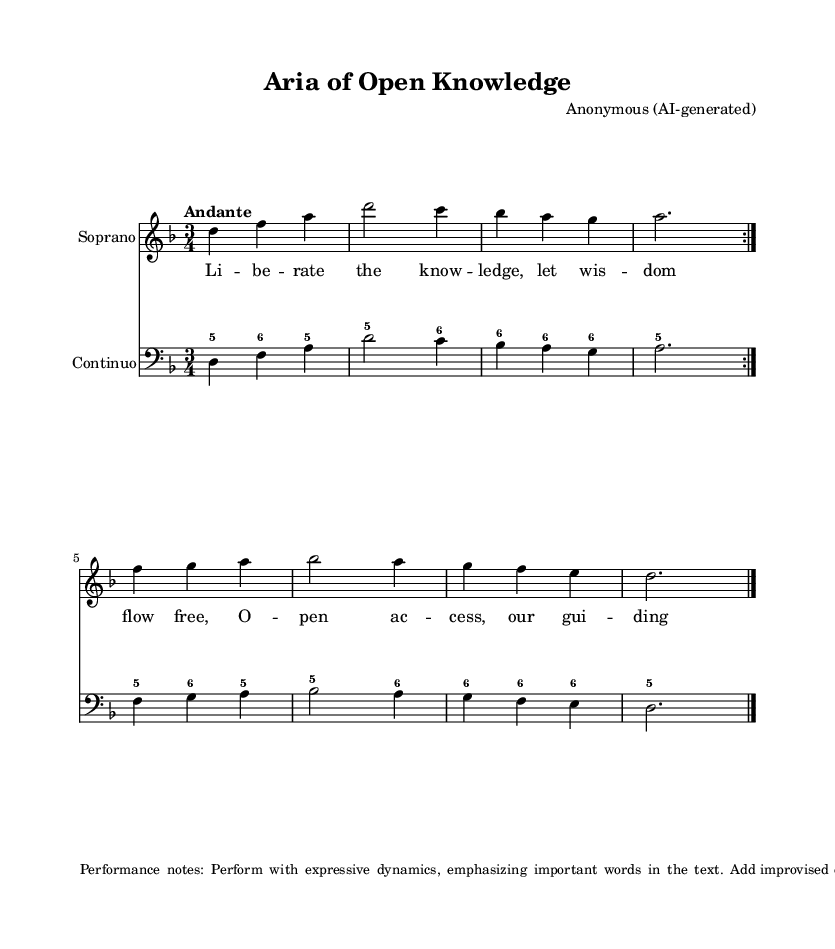What is the key signature of this music? The key signature is D minor, which has one flat (B flat). This can be determined by looking at the key signature at the beginning of the staff where the note B is indicated as flat.
Answer: D minor What is the time signature of this music? The time signature is 3/4, indicated at the beginning of the score. It shows that there are three beats in each measure and the quarter note gets one beat.
Answer: 3/4 What is the tempo marking for this piece? The tempo marking is "Andante". This is located at the beginning of the staff, indicating a moderately slow tempo.
Answer: Andante How many measures are in the A section before the repeat? There are four measures in the A section before the repeat. This can be identified by counting the measures in each part of the soprano line leading up to the first volta repeat sign.
Answer: 4 Which instruments are involved in the score? The score involves a Soprano voice and Continuo instrument. This is noted at the beginning of each staff where the instruments are labeled.
Answer: Soprano, Continuo What embellishments are suggested for the performance? The performance notes suggest adding improvised embellishments during the da capo repeat. This information is found in the markup at the bottom of the sheet music, which provides guidelines for expressive performance.
Answer: Improvised embellishments What is the main theme expressed in the lyrics of this aria? The main theme expressed in the lyrics is the idea of open access and freedom of knowledge. This can be understood by analyzing the words set to the music where phrases like "liberate the knowledge" highlight this theme.
Answer: Open access and knowledge freedom 